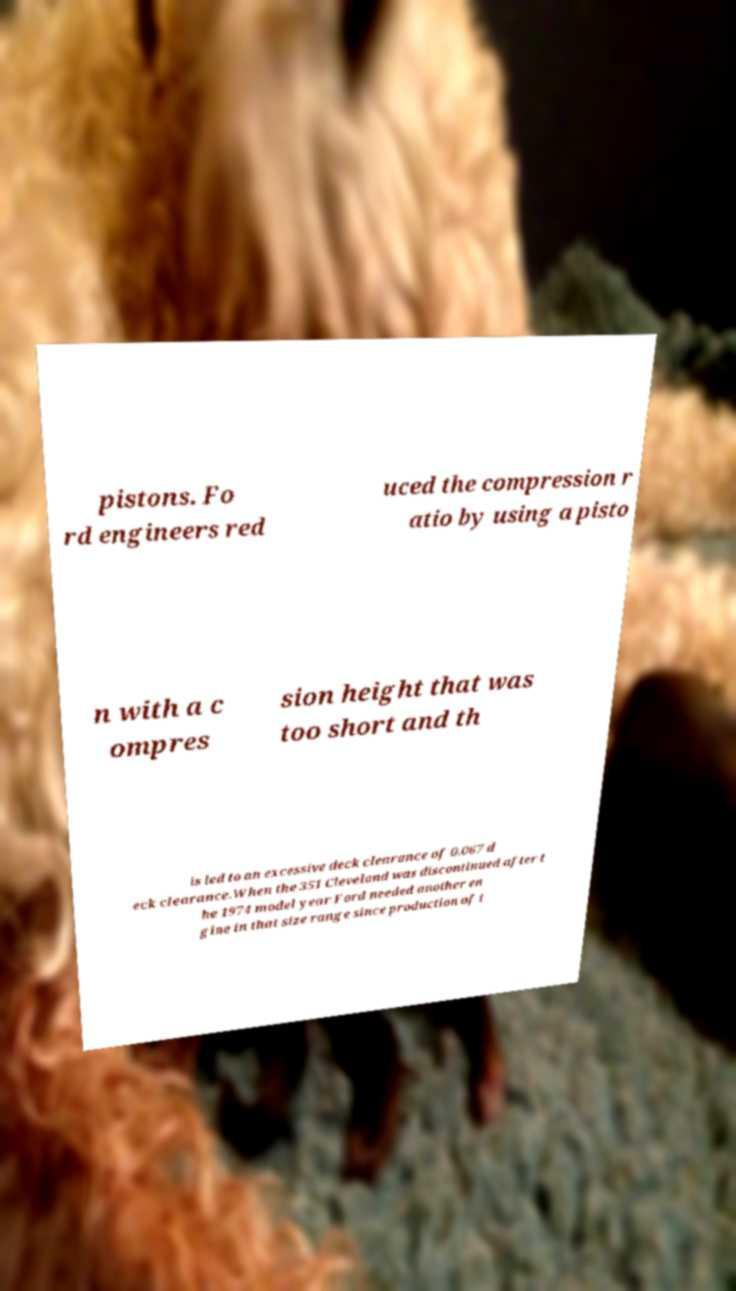For documentation purposes, I need the text within this image transcribed. Could you provide that? pistons. Fo rd engineers red uced the compression r atio by using a pisto n with a c ompres sion height that was too short and th is led to an excessive deck clearance of 0.067 d eck clearance.When the 351 Cleveland was discontinued after t he 1974 model year Ford needed another en gine in that size range since production of t 